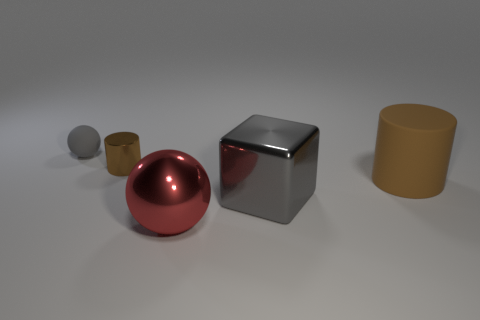Subtract all blue blocks. Subtract all red cylinders. How many blocks are left? 1 Subtract all green balls. How many red cylinders are left? 0 Add 4 things. How many reds exist? 0 Subtract all green metal spheres. Subtract all large red metallic objects. How many objects are left? 4 Add 3 shiny balls. How many shiny balls are left? 4 Add 1 big brown matte cylinders. How many big brown matte cylinders exist? 2 Add 3 big blue metal blocks. How many objects exist? 8 Subtract all gray spheres. How many spheres are left? 1 Subtract 0 purple cylinders. How many objects are left? 5 Subtract all brown cylinders. How many were subtracted if there are1brown cylinders left? 1 